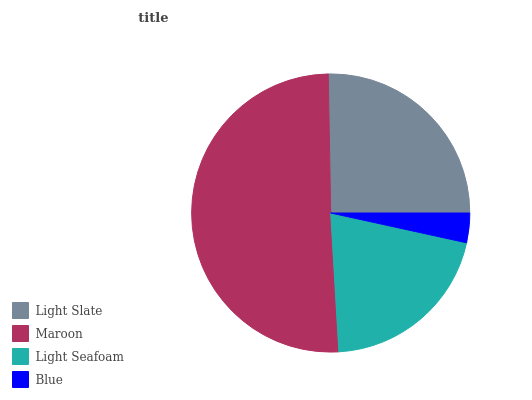Is Blue the minimum?
Answer yes or no. Yes. Is Maroon the maximum?
Answer yes or no. Yes. Is Light Seafoam the minimum?
Answer yes or no. No. Is Light Seafoam the maximum?
Answer yes or no. No. Is Maroon greater than Light Seafoam?
Answer yes or no. Yes. Is Light Seafoam less than Maroon?
Answer yes or no. Yes. Is Light Seafoam greater than Maroon?
Answer yes or no. No. Is Maroon less than Light Seafoam?
Answer yes or no. No. Is Light Slate the high median?
Answer yes or no. Yes. Is Light Seafoam the low median?
Answer yes or no. Yes. Is Maroon the high median?
Answer yes or no. No. Is Blue the low median?
Answer yes or no. No. 